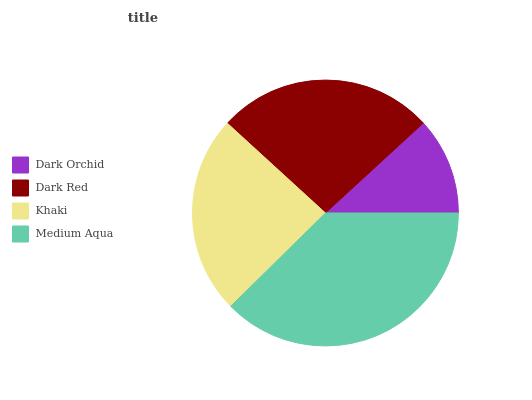Is Dark Orchid the minimum?
Answer yes or no. Yes. Is Medium Aqua the maximum?
Answer yes or no. Yes. Is Dark Red the minimum?
Answer yes or no. No. Is Dark Red the maximum?
Answer yes or no. No. Is Dark Red greater than Dark Orchid?
Answer yes or no. Yes. Is Dark Orchid less than Dark Red?
Answer yes or no. Yes. Is Dark Orchid greater than Dark Red?
Answer yes or no. No. Is Dark Red less than Dark Orchid?
Answer yes or no. No. Is Dark Red the high median?
Answer yes or no. Yes. Is Khaki the low median?
Answer yes or no. Yes. Is Khaki the high median?
Answer yes or no. No. Is Medium Aqua the low median?
Answer yes or no. No. 